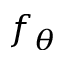<formula> <loc_0><loc_0><loc_500><loc_500>f _ { \theta }</formula> 